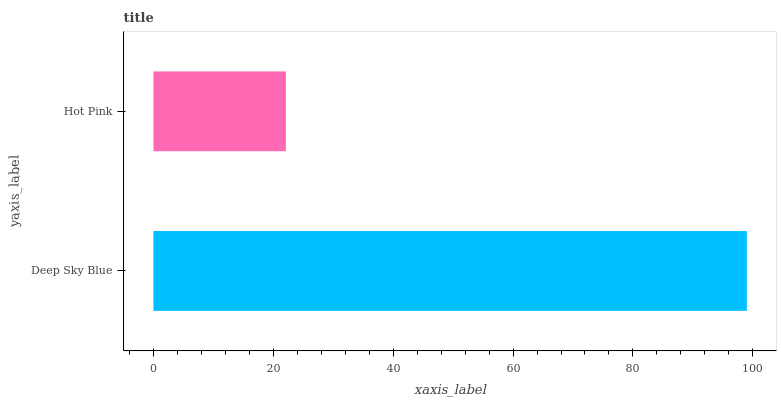Is Hot Pink the minimum?
Answer yes or no. Yes. Is Deep Sky Blue the maximum?
Answer yes or no. Yes. Is Hot Pink the maximum?
Answer yes or no. No. Is Deep Sky Blue greater than Hot Pink?
Answer yes or no. Yes. Is Hot Pink less than Deep Sky Blue?
Answer yes or no. Yes. Is Hot Pink greater than Deep Sky Blue?
Answer yes or no. No. Is Deep Sky Blue less than Hot Pink?
Answer yes or no. No. Is Deep Sky Blue the high median?
Answer yes or no. Yes. Is Hot Pink the low median?
Answer yes or no. Yes. Is Hot Pink the high median?
Answer yes or no. No. Is Deep Sky Blue the low median?
Answer yes or no. No. 